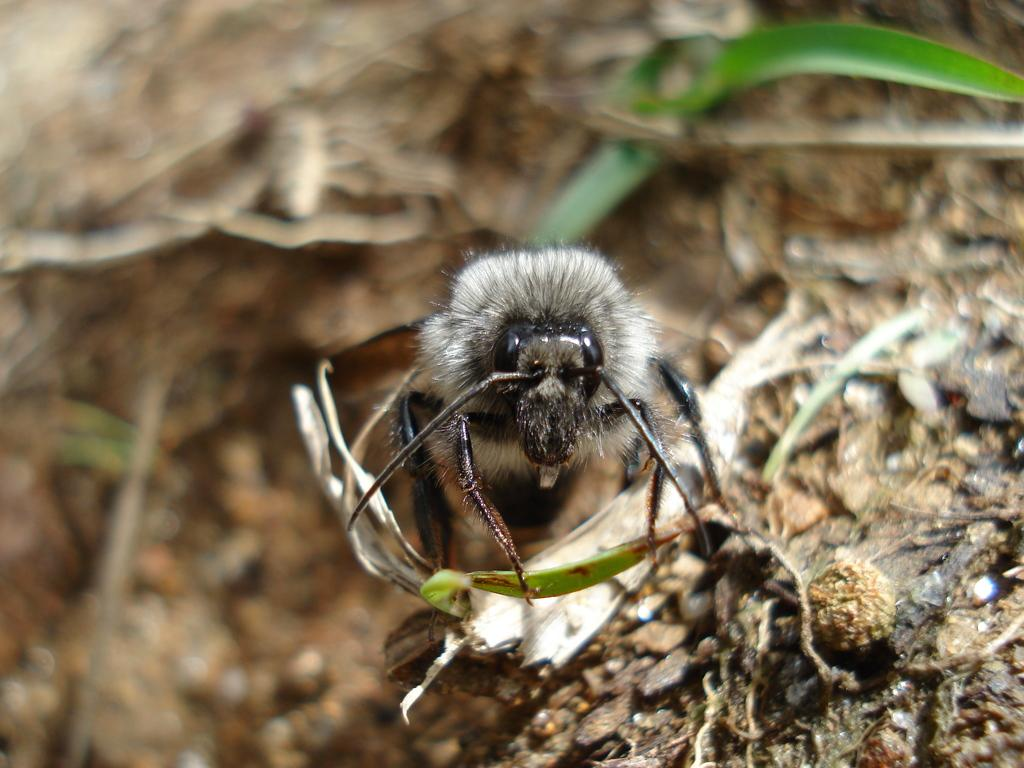What type of creature can be seen in the image? There is an insect in the image. What can be found on the ground in the image? There are dried leaves on the ground in the image. What effect does the volcano have on the insect in the image? There is no volcano present in the image, so it cannot have any effect on the insect. 